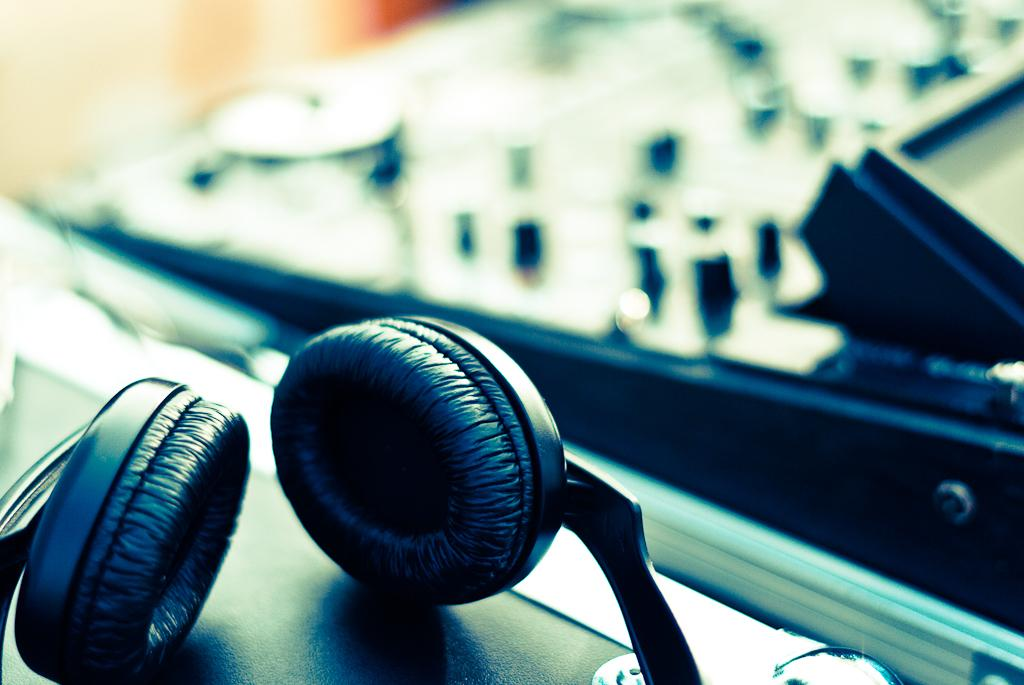What is the main object in the image? There is a headset in the image. Where is the headset located? The headset is placed on a surface. Can you describe anything in the background of the image? There is an object in the background of the image. How many apples are hanging from the wire in the image? There is no wire or apples present in the image. What type of produce can be seen in the image? There is no produce visible in the image. 